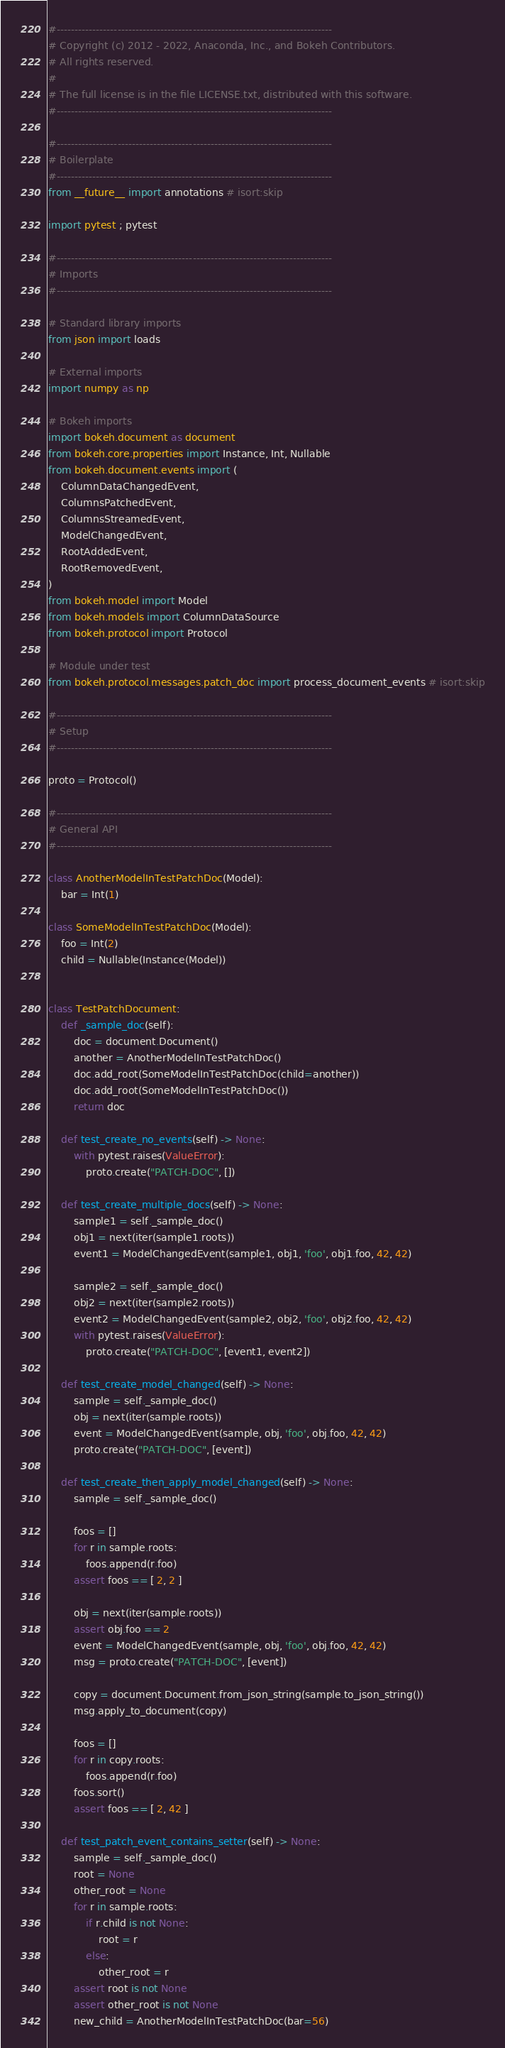Convert code to text. <code><loc_0><loc_0><loc_500><loc_500><_Python_>#-----------------------------------------------------------------------------
# Copyright (c) 2012 - 2022, Anaconda, Inc., and Bokeh Contributors.
# All rights reserved.
#
# The full license is in the file LICENSE.txt, distributed with this software.
#-----------------------------------------------------------------------------

#-----------------------------------------------------------------------------
# Boilerplate
#-----------------------------------------------------------------------------
from __future__ import annotations # isort:skip

import pytest ; pytest

#-----------------------------------------------------------------------------
# Imports
#-----------------------------------------------------------------------------

# Standard library imports
from json import loads

# External imports
import numpy as np

# Bokeh imports
import bokeh.document as document
from bokeh.core.properties import Instance, Int, Nullable
from bokeh.document.events import (
    ColumnDataChangedEvent,
    ColumnsPatchedEvent,
    ColumnsStreamedEvent,
    ModelChangedEvent,
    RootAddedEvent,
    RootRemovedEvent,
)
from bokeh.model import Model
from bokeh.models import ColumnDataSource
from bokeh.protocol import Protocol

# Module under test
from bokeh.protocol.messages.patch_doc import process_document_events # isort:skip

#-----------------------------------------------------------------------------
# Setup
#-----------------------------------------------------------------------------

proto = Protocol()

#-----------------------------------------------------------------------------
# General API
#-----------------------------------------------------------------------------

class AnotherModelInTestPatchDoc(Model):
    bar = Int(1)

class SomeModelInTestPatchDoc(Model):
    foo = Int(2)
    child = Nullable(Instance(Model))


class TestPatchDocument:
    def _sample_doc(self):
        doc = document.Document()
        another = AnotherModelInTestPatchDoc()
        doc.add_root(SomeModelInTestPatchDoc(child=another))
        doc.add_root(SomeModelInTestPatchDoc())
        return doc

    def test_create_no_events(self) -> None:
        with pytest.raises(ValueError):
            proto.create("PATCH-DOC", [])

    def test_create_multiple_docs(self) -> None:
        sample1 = self._sample_doc()
        obj1 = next(iter(sample1.roots))
        event1 = ModelChangedEvent(sample1, obj1, 'foo', obj1.foo, 42, 42)

        sample2 = self._sample_doc()
        obj2 = next(iter(sample2.roots))
        event2 = ModelChangedEvent(sample2, obj2, 'foo', obj2.foo, 42, 42)
        with pytest.raises(ValueError):
            proto.create("PATCH-DOC", [event1, event2])

    def test_create_model_changed(self) -> None:
        sample = self._sample_doc()
        obj = next(iter(sample.roots))
        event = ModelChangedEvent(sample, obj, 'foo', obj.foo, 42, 42)
        proto.create("PATCH-DOC", [event])

    def test_create_then_apply_model_changed(self) -> None:
        sample = self._sample_doc()

        foos = []
        for r in sample.roots:
            foos.append(r.foo)
        assert foos == [ 2, 2 ]

        obj = next(iter(sample.roots))
        assert obj.foo == 2
        event = ModelChangedEvent(sample, obj, 'foo', obj.foo, 42, 42)
        msg = proto.create("PATCH-DOC", [event])

        copy = document.Document.from_json_string(sample.to_json_string())
        msg.apply_to_document(copy)

        foos = []
        for r in copy.roots:
            foos.append(r.foo)
        foos.sort()
        assert foos == [ 2, 42 ]

    def test_patch_event_contains_setter(self) -> None:
        sample = self._sample_doc()
        root = None
        other_root = None
        for r in sample.roots:
            if r.child is not None:
                root = r
            else:
                other_root = r
        assert root is not None
        assert other_root is not None
        new_child = AnotherModelInTestPatchDoc(bar=56)
</code> 